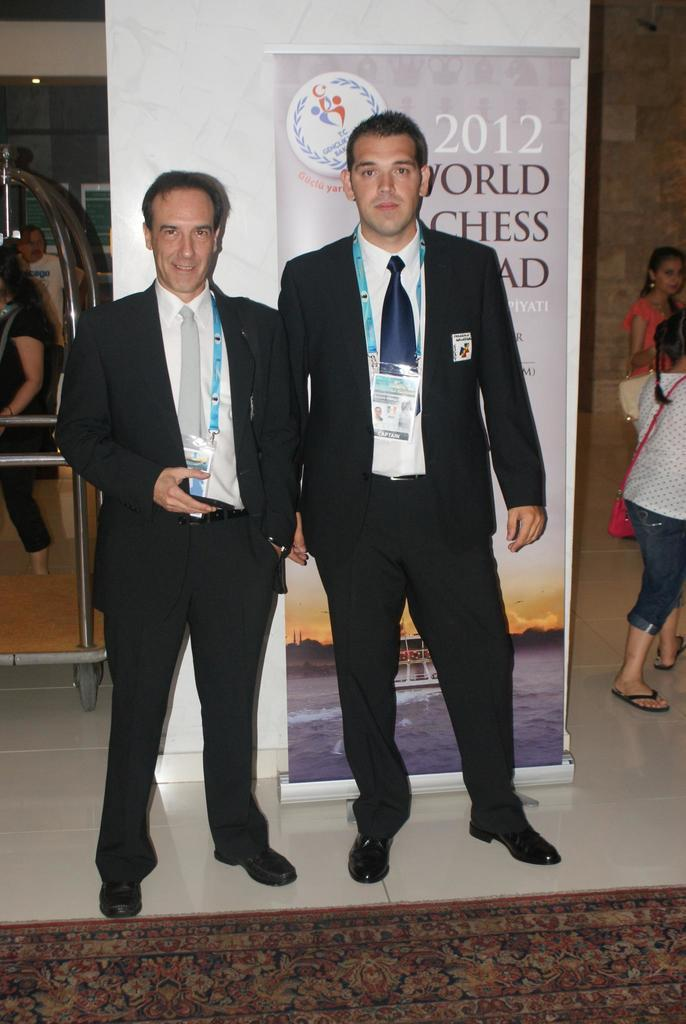How many men are present in the image? There are two men in the image. What are the men wearing? The men are wearing blazers. Do the men have any identification in the image? Yes, the men have id cards. What is in the background behind the men? The men are standing in front of a banner. Are there any other people visible in the image? Yes, there are other people around them in the image. What type of pipe can be seen in the hands of one of the men in the image? There is no pipe present in the image; both men are holding id cards. 